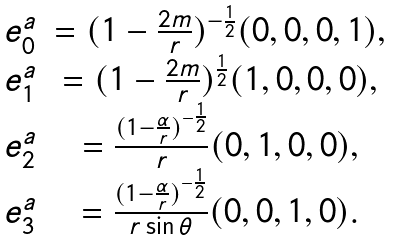Convert formula to latex. <formula><loc_0><loc_0><loc_500><loc_500>\begin{array} { c c c } e _ { 0 } ^ { a } & = ( 1 - \frac { 2 m } { r } ) ^ { - \frac { 1 } { 2 } } ( 0 , 0 , 0 , 1 ) , \\ e _ { 1 } ^ { a } & = ( 1 - \frac { 2 m } { r } ) ^ { \frac { 1 } { 2 } } ( 1 , 0 , 0 , 0 ) , \\ e ^ { a } _ { 2 } & = \frac { ( 1 - \frac { \alpha } { r } ) ^ { - \frac { 1 } { 2 } } } { r } ( 0 , 1 , 0 , 0 ) , \\ e ^ { a } _ { 3 } & = \frac { ( 1 - \frac { \alpha } { r } ) ^ { - \frac { 1 } { 2 } } } { r \sin \theta } ( 0 , 0 , 1 , 0 ) . \end{array}</formula> 